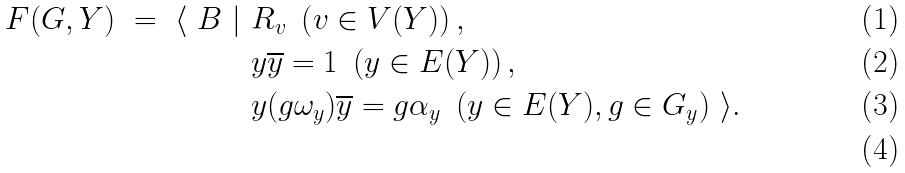Convert formula to latex. <formula><loc_0><loc_0><loc_500><loc_500>F ( G , Y ) \ = \ \langle \ B \ | \ & R _ { v } \ \left ( v \in V ( Y ) \right ) , \\ & y \overline { y } = 1 \ \left ( y \in E ( Y ) \right ) , \\ & y ( g \omega _ { y } ) \overline { y } = g \alpha _ { y } \ \left ( y \in E ( Y ) , g \in G _ { y } \right ) \ \rangle . \\</formula> 